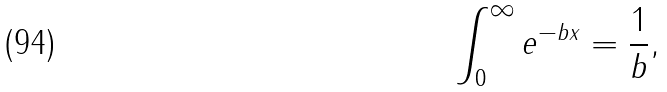Convert formula to latex. <formula><loc_0><loc_0><loc_500><loc_500>\int _ { 0 } ^ { \infty } e ^ { - b x } = \frac { 1 } { b } ,</formula> 